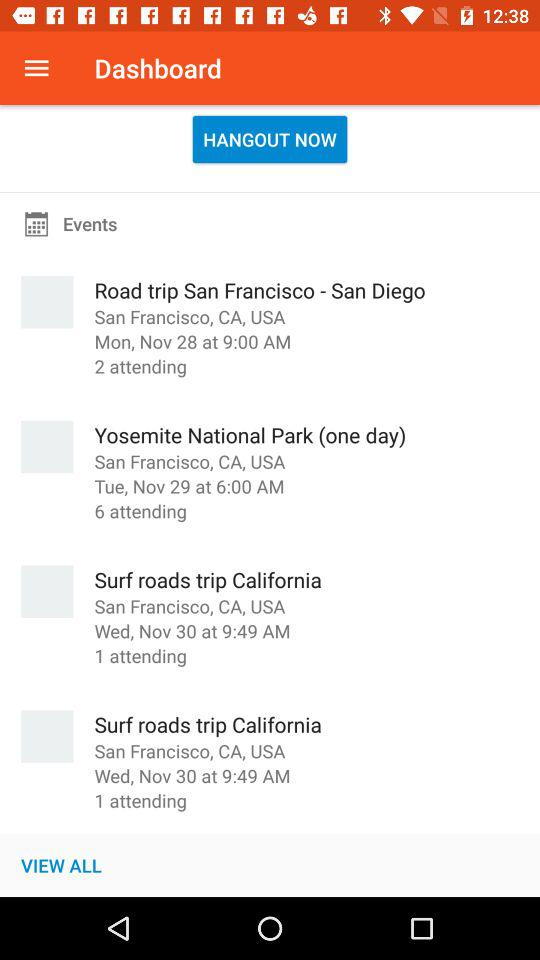How many people will be attending "Surf roads trip California"? "Surf roads trip California" will be attended by 1 person. 